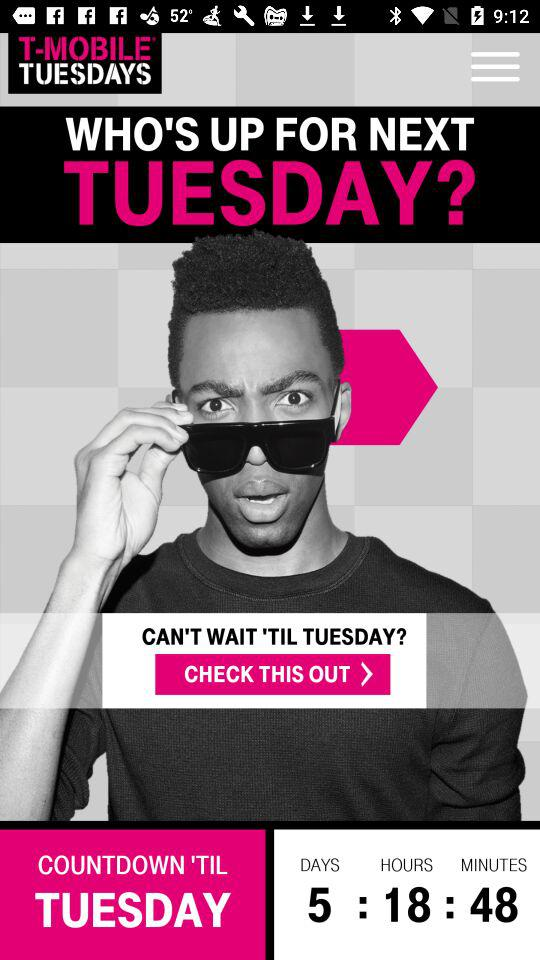What is the price of a movie ticket? The price of a movie ticket is $2. 